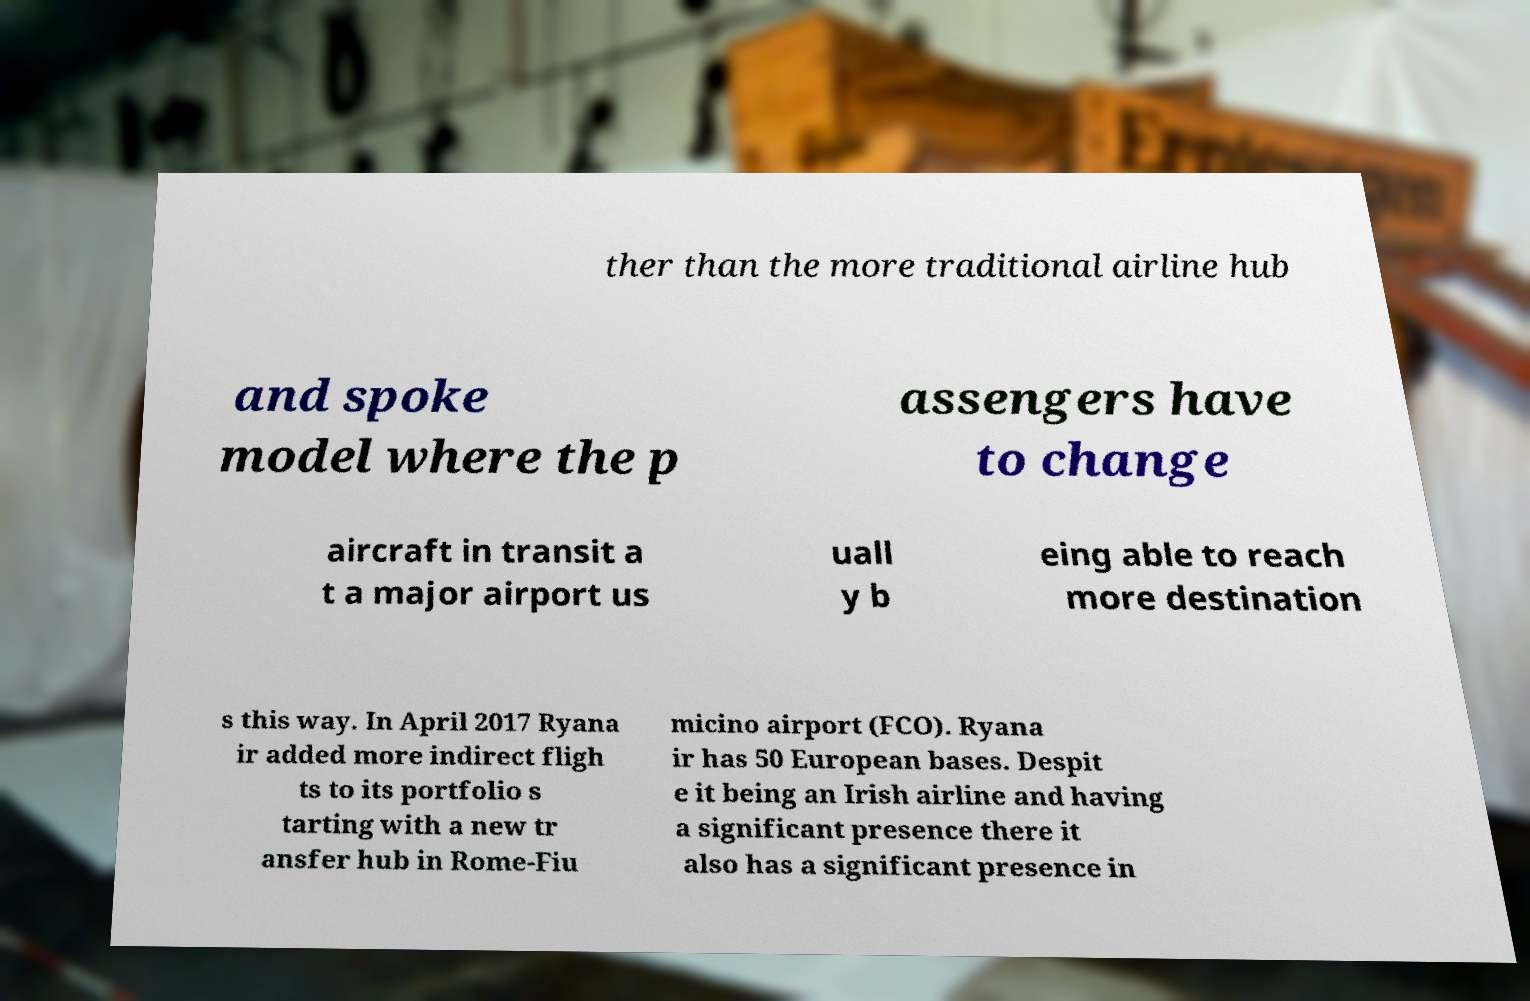Can you accurately transcribe the text from the provided image for me? ther than the more traditional airline hub and spoke model where the p assengers have to change aircraft in transit a t a major airport us uall y b eing able to reach more destination s this way. In April 2017 Ryana ir added more indirect fligh ts to its portfolio s tarting with a new tr ansfer hub in Rome-Fiu micino airport (FCO). Ryana ir has 50 European bases. Despit e it being an Irish airline and having a significant presence there it also has a significant presence in 